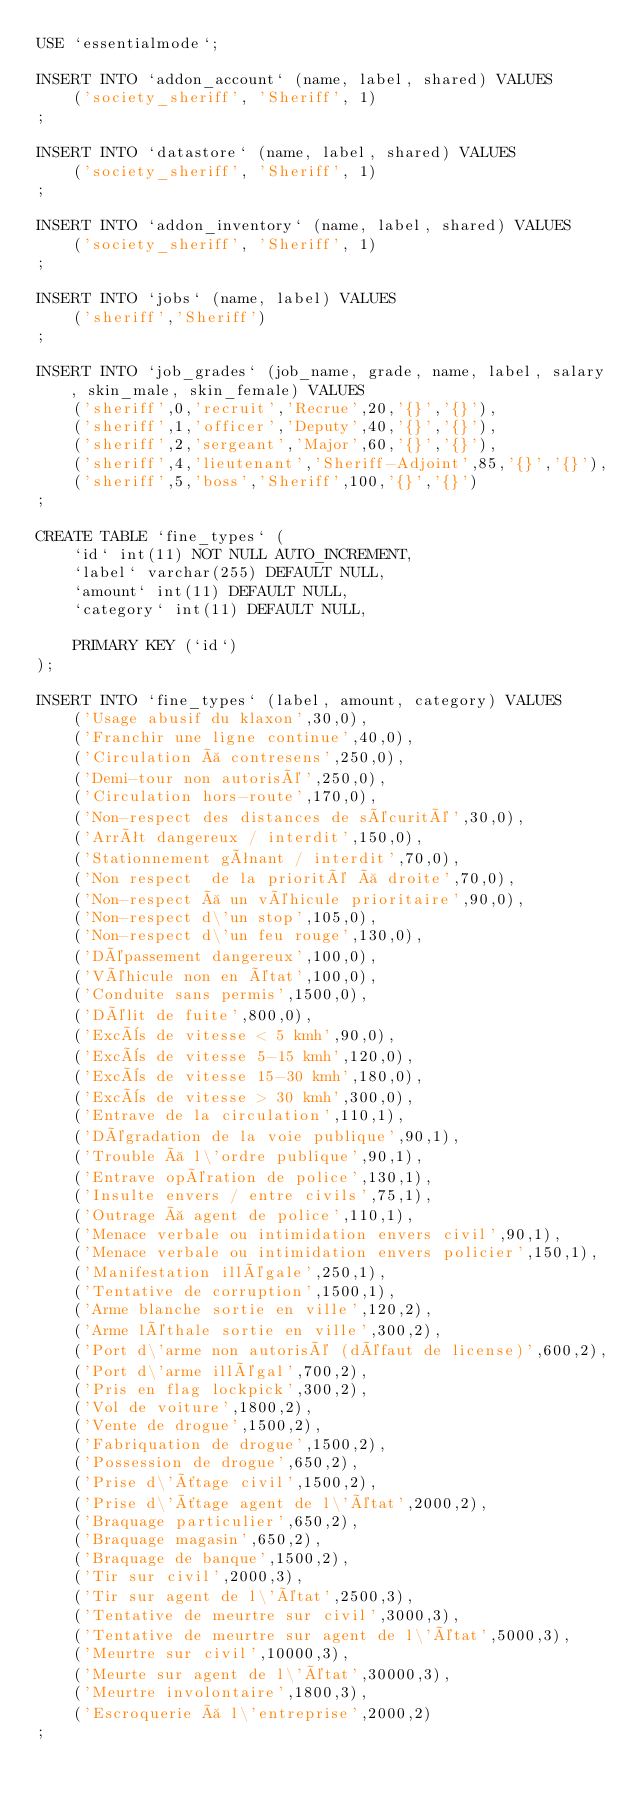<code> <loc_0><loc_0><loc_500><loc_500><_SQL_>USE `essentialmode`;

INSERT INTO `addon_account` (name, label, shared) VALUES
	('society_sheriff', 'Sheriff', 1)
;

INSERT INTO `datastore` (name, label, shared) VALUES
	('society_sheriff', 'Sheriff', 1)
;

INSERT INTO `addon_inventory` (name, label, shared) VALUES
	('society_sheriff', 'Sheriff', 1)
;

INSERT INTO `jobs` (name, label) VALUES
	('sheriff','Sheriff')
;

INSERT INTO `job_grades` (job_name, grade, name, label, salary, skin_male, skin_female) VALUES
	('sheriff',0,'recruit','Recrue',20,'{}','{}'),
	('sheriff',1,'officer','Deputy',40,'{}','{}'),
	('sheriff',2,'sergeant','Major',60,'{}','{}'),
	('sheriff',4,'lieutenant','Sheriff-Adjoint',85,'{}','{}'),
	('sheriff',5,'boss','Sheriff',100,'{}','{}')
;

CREATE TABLE `fine_types` (
	`id` int(11) NOT NULL AUTO_INCREMENT,
	`label` varchar(255) DEFAULT NULL,
	`amount` int(11) DEFAULT NULL,
	`category` int(11) DEFAULT NULL,

	PRIMARY KEY (`id`)
);

INSERT INTO `fine_types` (label, amount, category) VALUES
	('Usage abusif du klaxon',30,0),
	('Franchir une ligne continue',40,0),
	('Circulation à contresens',250,0),
	('Demi-tour non autorisé',250,0),
	('Circulation hors-route',170,0),
	('Non-respect des distances de sécurité',30,0),
	('Arrêt dangereux / interdit',150,0),
	('Stationnement gênant / interdit',70,0),
	('Non respect  de la priorité à droite',70,0),
	('Non-respect à un véhicule prioritaire',90,0),
	('Non-respect d\'un stop',105,0),
	('Non-respect d\'un feu rouge',130,0),
	('Dépassement dangereux',100,0),
	('Véhicule non en état',100,0),
	('Conduite sans permis',1500,0),
	('Délit de fuite',800,0),
	('Excès de vitesse < 5 kmh',90,0),
	('Excès de vitesse 5-15 kmh',120,0),
	('Excès de vitesse 15-30 kmh',180,0),
	('Excès de vitesse > 30 kmh',300,0),
	('Entrave de la circulation',110,1),
	('Dégradation de la voie publique',90,1),
	('Trouble à l\'ordre publique',90,1),
	('Entrave opération de police',130,1),
	('Insulte envers / entre civils',75,1),
	('Outrage à agent de police',110,1),
	('Menace verbale ou intimidation envers civil',90,1),
	('Menace verbale ou intimidation envers policier',150,1),
	('Manifestation illégale',250,1),
	('Tentative de corruption',1500,1),
	('Arme blanche sortie en ville',120,2),
	('Arme léthale sortie en ville',300,2),
	('Port d\'arme non autorisé (défaut de license)',600,2),
	('Port d\'arme illégal',700,2),
	('Pris en flag lockpick',300,2),
	('Vol de voiture',1800,2),
	('Vente de drogue',1500,2),
	('Fabriquation de drogue',1500,2),
	('Possession de drogue',650,2),
	('Prise d\'ôtage civil',1500,2),
	('Prise d\'ôtage agent de l\'état',2000,2),
	('Braquage particulier',650,2),
	('Braquage magasin',650,2),
	('Braquage de banque',1500,2),
	('Tir sur civil',2000,3),
	('Tir sur agent de l\'état',2500,3),
	('Tentative de meurtre sur civil',3000,3),
	('Tentative de meurtre sur agent de l\'état',5000,3),
	('Meurtre sur civil',10000,3),
	('Meurte sur agent de l\'état',30000,3),
	('Meurtre involontaire',1800,3),
	('Escroquerie à l\'entreprise',2000,2)
;
</code> 